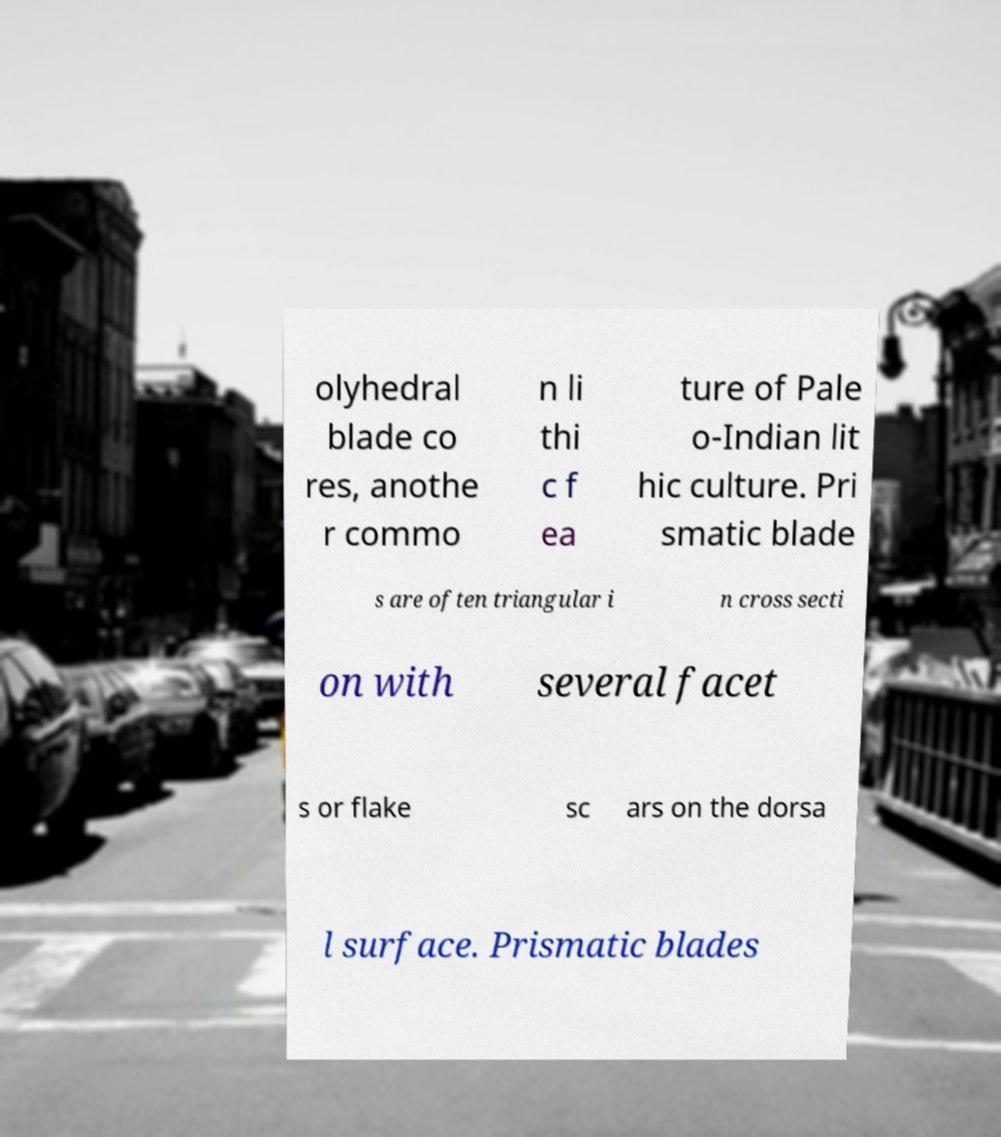Please identify and transcribe the text found in this image. olyhedral blade co res, anothe r commo n li thi c f ea ture of Pale o-Indian lit hic culture. Pri smatic blade s are often triangular i n cross secti on with several facet s or flake sc ars on the dorsa l surface. Prismatic blades 